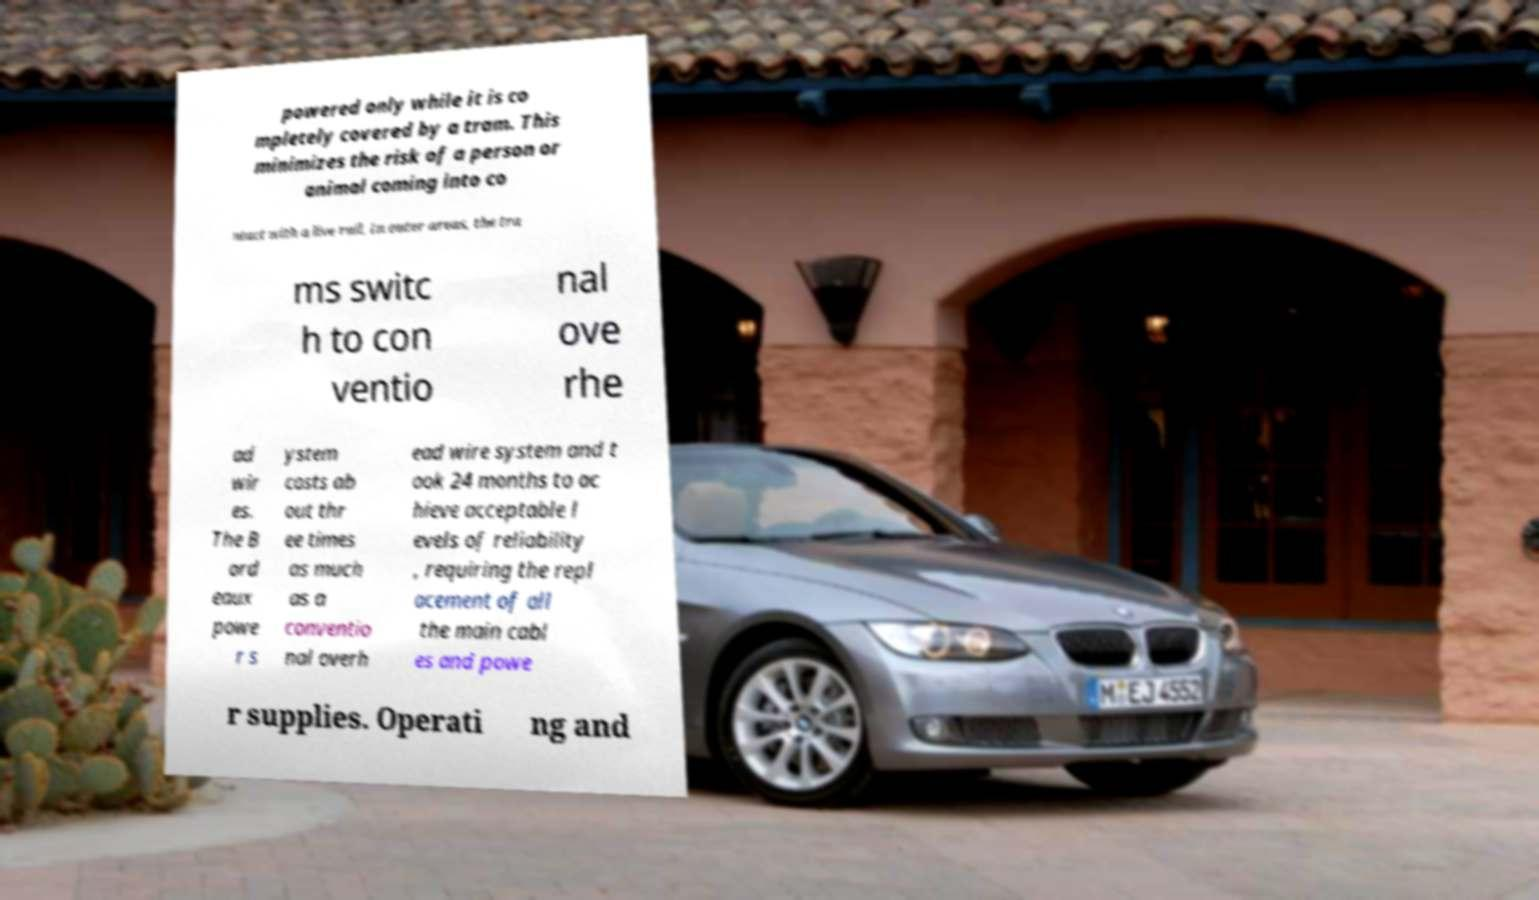Please read and relay the text visible in this image. What does it say? powered only while it is co mpletely covered by a tram. This minimizes the risk of a person or animal coming into co ntact with a live rail. In outer areas, the tra ms switc h to con ventio nal ove rhe ad wir es. The B ord eaux powe r s ystem costs ab out thr ee times as much as a conventio nal overh ead wire system and t ook 24 months to ac hieve acceptable l evels of reliability , requiring the repl acement of all the main cabl es and powe r supplies. Operati ng and 